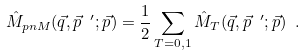Convert formula to latex. <formula><loc_0><loc_0><loc_500><loc_500>\hat { M } _ { p n M } ( \vec { q } , \vec { p } \ ^ { \prime } ; \vec { p } ) = \frac { 1 } { 2 } \sum _ { T = 0 , 1 } \hat { M } _ { T } ( \vec { q } , \vec { p } \ ^ { \prime } ; \vec { p } ) \ .</formula> 